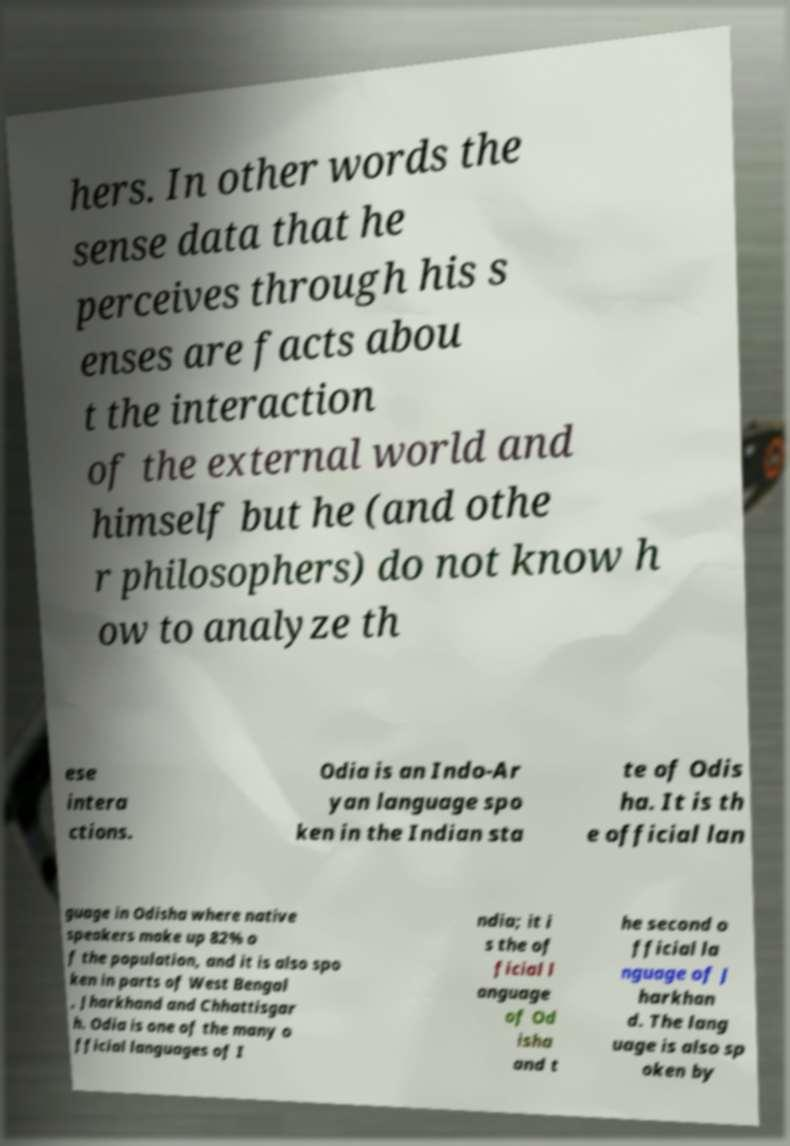Can you read and provide the text displayed in the image?This photo seems to have some interesting text. Can you extract and type it out for me? hers. In other words the sense data that he perceives through his s enses are facts abou t the interaction of the external world and himself but he (and othe r philosophers) do not know h ow to analyze th ese intera ctions. Odia is an Indo-Ar yan language spo ken in the Indian sta te of Odis ha. It is th e official lan guage in Odisha where native speakers make up 82% o f the population, and it is also spo ken in parts of West Bengal , Jharkhand and Chhattisgar h. Odia is one of the many o fficial languages of I ndia; it i s the of ficial l anguage of Od isha and t he second o fficial la nguage of J harkhan d. The lang uage is also sp oken by 